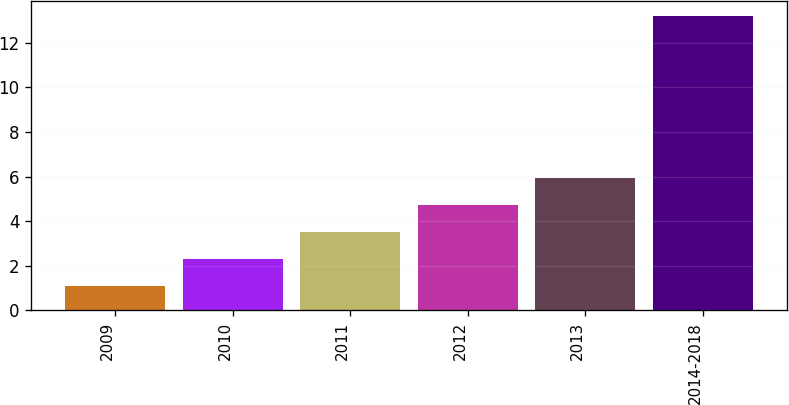Convert chart to OTSL. <chart><loc_0><loc_0><loc_500><loc_500><bar_chart><fcel>2009<fcel>2010<fcel>2011<fcel>2012<fcel>2013<fcel>2014-2018<nl><fcel>1.1<fcel>2.31<fcel>3.52<fcel>4.73<fcel>5.94<fcel>13.2<nl></chart> 